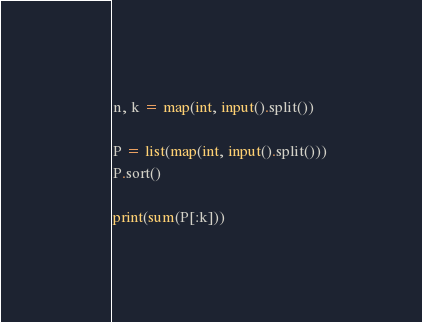Convert code to text. <code><loc_0><loc_0><loc_500><loc_500><_Python_>n, k = map(int, input().split())

P = list(map(int, input().split()))
P.sort()

print(sum(P[:k]))
</code> 